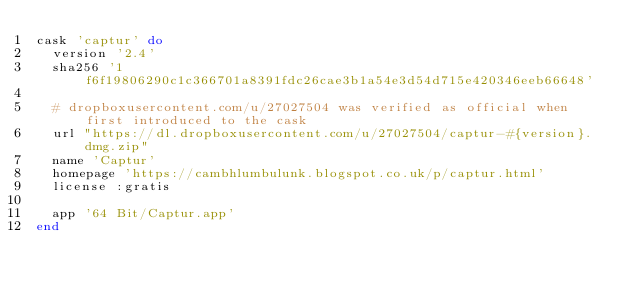<code> <loc_0><loc_0><loc_500><loc_500><_Ruby_>cask 'captur' do
  version '2.4'
  sha256 '1f6f19806290c1c366701a8391fdc26cae3b1a54e3d54d715e420346eeb66648'

  # dropboxusercontent.com/u/27027504 was verified as official when first introduced to the cask
  url "https://dl.dropboxusercontent.com/u/27027504/captur-#{version}.dmg.zip"
  name 'Captur'
  homepage 'https://cambhlumbulunk.blogspot.co.uk/p/captur.html'
  license :gratis

  app '64 Bit/Captur.app'
end
</code> 